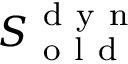<formula> <loc_0><loc_0><loc_500><loc_500>S _ { o l d } ^ { d y n }</formula> 